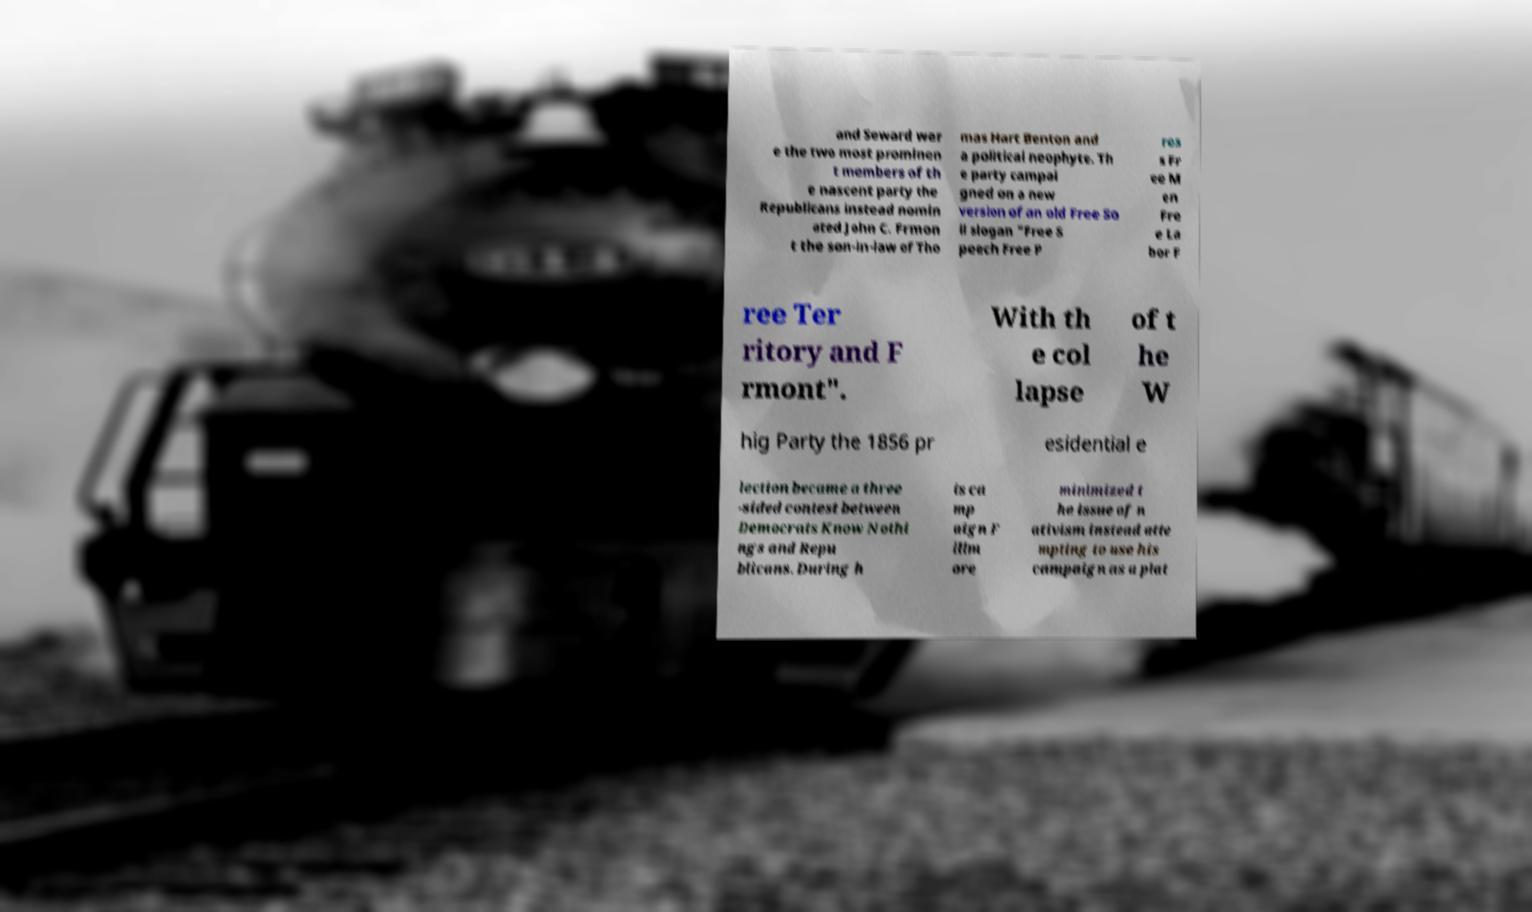There's text embedded in this image that I need extracted. Can you transcribe it verbatim? and Seward wer e the two most prominen t members of th e nascent party the Republicans instead nomin ated John C. Frmon t the son-in-law of Tho mas Hart Benton and a political neophyte. Th e party campai gned on a new version of an old Free So il slogan "Free S peech Free P res s Fr ee M en Fre e La bor F ree Ter ritory and F rmont". With th e col lapse of t he W hig Party the 1856 pr esidential e lection became a three -sided contest between Democrats Know Nothi ngs and Repu blicans. During h is ca mp aign F illm ore minimized t he issue of n ativism instead atte mpting to use his campaign as a plat 